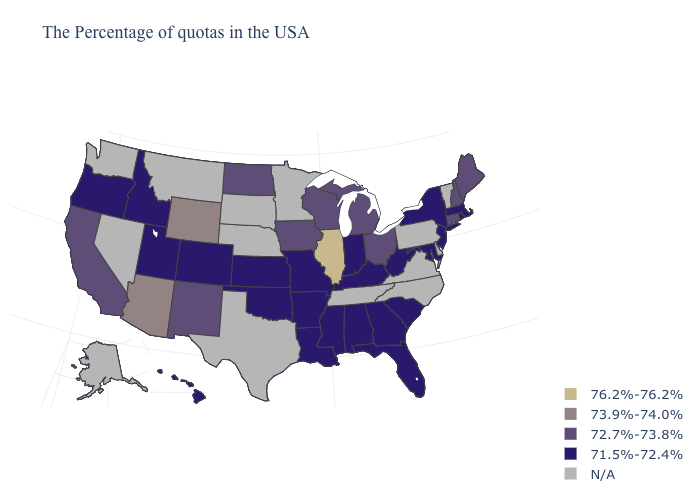What is the highest value in the South ?
Quick response, please. 71.5%-72.4%. Is the legend a continuous bar?
Short answer required. No. Which states hav the highest value in the South?
Give a very brief answer. Maryland, South Carolina, West Virginia, Florida, Georgia, Kentucky, Alabama, Mississippi, Louisiana, Arkansas, Oklahoma. What is the lowest value in states that border Idaho?
Concise answer only. 71.5%-72.4%. What is the highest value in the USA?
Write a very short answer. 76.2%-76.2%. Among the states that border Arizona , does New Mexico have the lowest value?
Be succinct. No. Name the states that have a value in the range 76.2%-76.2%?
Answer briefly. Illinois. Is the legend a continuous bar?
Write a very short answer. No. What is the lowest value in the USA?
Be succinct. 71.5%-72.4%. Does New York have the highest value in the Northeast?
Be succinct. No. Does Illinois have the highest value in the USA?
Write a very short answer. Yes. 